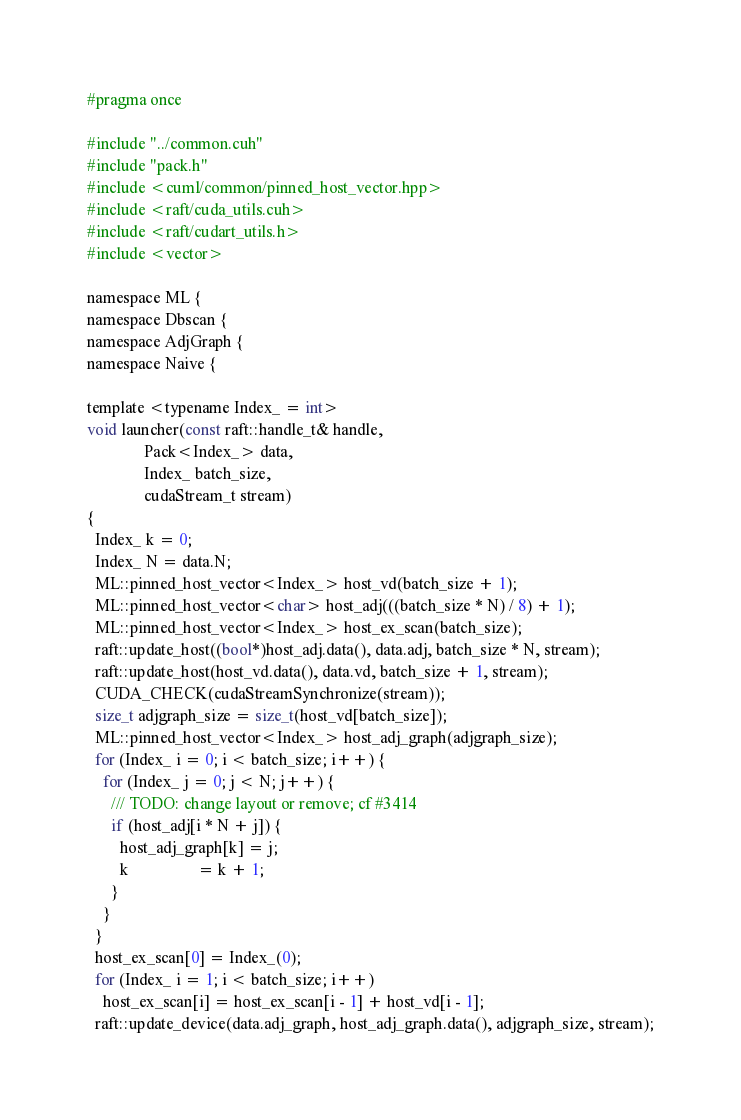Convert code to text. <code><loc_0><loc_0><loc_500><loc_500><_Cuda_>
#pragma once

#include "../common.cuh"
#include "pack.h"
#include <cuml/common/pinned_host_vector.hpp>
#include <raft/cuda_utils.cuh>
#include <raft/cudart_utils.h>
#include <vector>

namespace ML {
namespace Dbscan {
namespace AdjGraph {
namespace Naive {

template <typename Index_ = int>
void launcher(const raft::handle_t& handle,
              Pack<Index_> data,
              Index_ batch_size,
              cudaStream_t stream)
{
  Index_ k = 0;
  Index_ N = data.N;
  ML::pinned_host_vector<Index_> host_vd(batch_size + 1);
  ML::pinned_host_vector<char> host_adj(((batch_size * N) / 8) + 1);
  ML::pinned_host_vector<Index_> host_ex_scan(batch_size);
  raft::update_host((bool*)host_adj.data(), data.adj, batch_size * N, stream);
  raft::update_host(host_vd.data(), data.vd, batch_size + 1, stream);
  CUDA_CHECK(cudaStreamSynchronize(stream));
  size_t adjgraph_size = size_t(host_vd[batch_size]);
  ML::pinned_host_vector<Index_> host_adj_graph(adjgraph_size);
  for (Index_ i = 0; i < batch_size; i++) {
    for (Index_ j = 0; j < N; j++) {
      /// TODO: change layout or remove; cf #3414
      if (host_adj[i * N + j]) {
        host_adj_graph[k] = j;
        k                 = k + 1;
      }
    }
  }
  host_ex_scan[0] = Index_(0);
  for (Index_ i = 1; i < batch_size; i++)
    host_ex_scan[i] = host_ex_scan[i - 1] + host_vd[i - 1];
  raft::update_device(data.adj_graph, host_adj_graph.data(), adjgraph_size, stream);</code> 